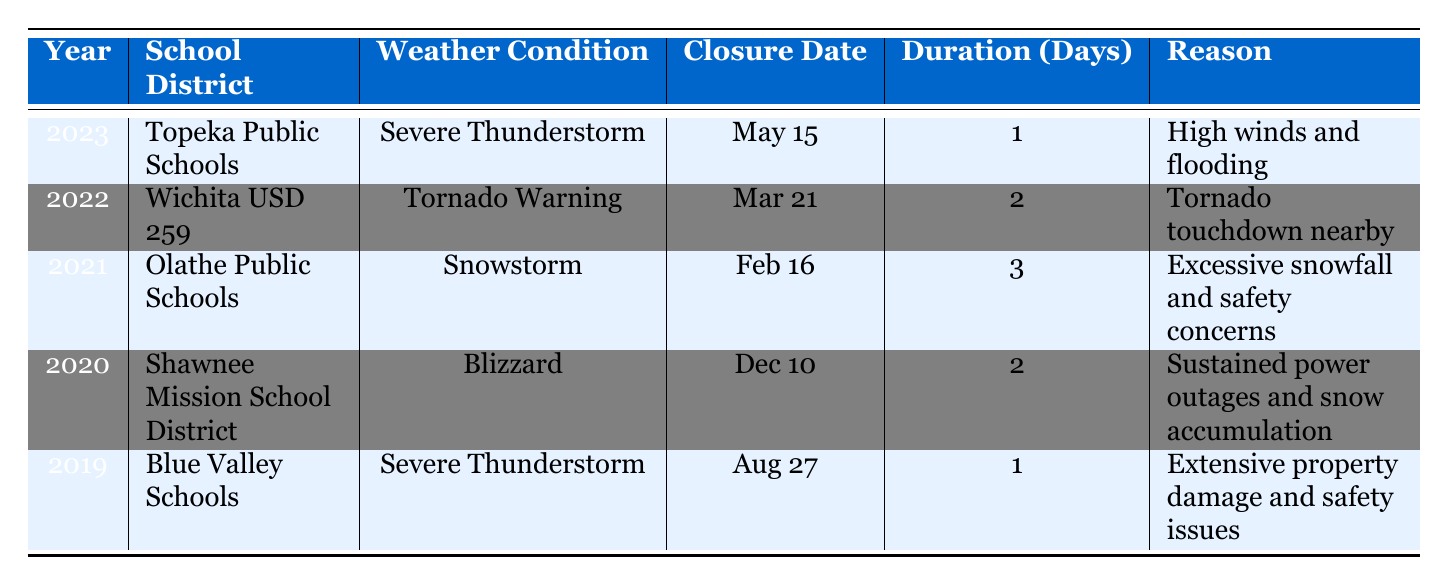What was the weather condition for the school closure on May 15, 2023? The date May 15, 2023, corresponds to the entry for Topeka Public Schools, which lists the weather condition as Severe Thunderstorm.
Answer: Severe Thunderstorm How many days were the schools closed in total in 2022? According to the table, there was one closure in 2022 (Wichita USD 259) and it lasted for 2 days. Since there is only one entry, the total is simply the duration from that entry, which is 2 days.
Answer: 2 days Did any school districts close due to a tornado warning? Yes, reviewing the table shows that Wichita USD 259 closed due to a Tornado Warning on March 21, 2022.
Answer: Yes Which school had the longest closure duration recorded? Examining the duration column, Olathe Public Schools had a closure of 3 days for a Snowstorm on February 16, 2021, which is longer than any other recorded closures in the table.
Answer: Olathe Public Schools What was the average duration of closures across all entries? To find the average duration, sum all the durations: 1 + 2 + 3 + 2 + 1 = 9. Then divide by the number of entries (5): 9 / 5 = 1.8. Thus, the average duration of closures is 1.8 days.
Answer: 1.8 days How many school closures were due to thunderstorms? In the table, there are two entries related to thunderstorms: Topeka Public Schools (Severe Thunderstorm in 2023) and Blue Valley Schools (Severe Thunderstorm in 2019). Therefore, there were 2 closures related to thunderstorms.
Answer: 2 closures What is the reason for the school closure on February 16, 2021? The entry for Olathe Public Schools on February 16, 2021, lists the reason for closure as "Excessive snowfall and safety concerns."
Answer: Excessive snowfall and safety concerns Was there a school closure due to a blizzard in 2020? Yes, the table indicates that Shawnee Mission School District closed on December 10, 2020, due to a Blizzard.
Answer: Yes 